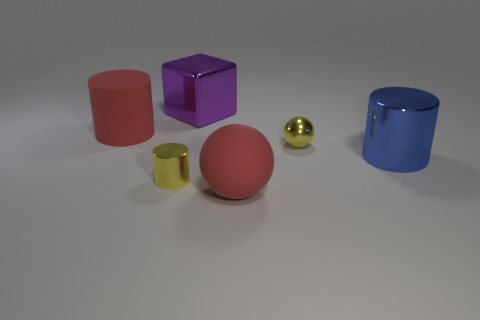Subtract all blue cylinders. How many cylinders are left? 2 Subtract all blue cylinders. How many cylinders are left? 2 Subtract all cubes. How many objects are left? 5 Add 3 tiny yellow shiny cylinders. How many objects exist? 9 Subtract all gray cubes. Subtract all purple spheres. How many cubes are left? 1 Subtract all brown spheres. How many yellow cylinders are left? 1 Subtract 2 spheres. How many spheres are left? 0 Subtract all small cyan rubber cylinders. Subtract all blue objects. How many objects are left? 5 Add 1 red cylinders. How many red cylinders are left? 2 Add 1 large yellow rubber things. How many large yellow rubber things exist? 1 